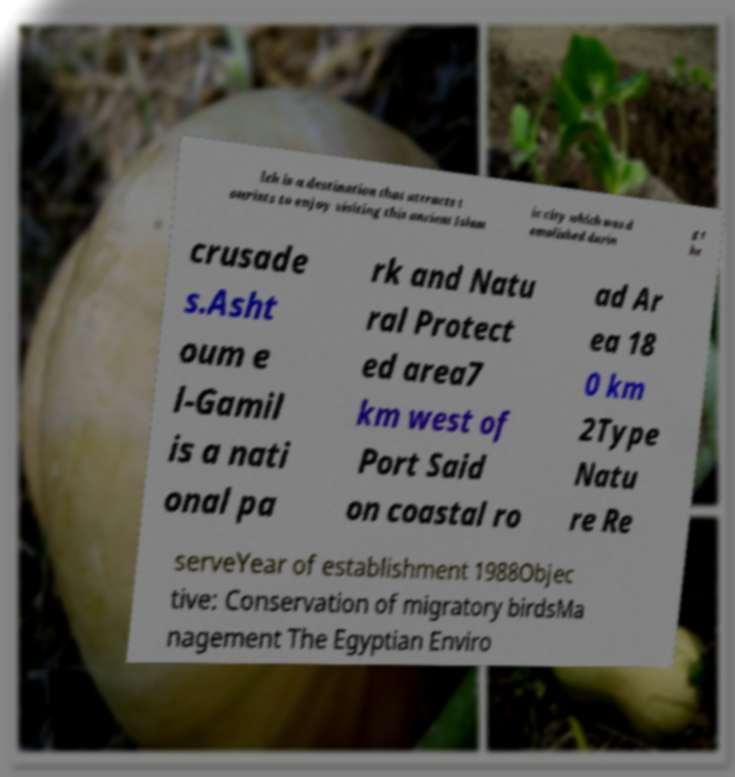Can you accurately transcribe the text from the provided image for me? leh is a destination that attracts t ourists to enjoy visiting this ancient Islam ic city which was d emolished durin g t he crusade s.Asht oum e l-Gamil is a nati onal pa rk and Natu ral Protect ed area7 km west of Port Said on coastal ro ad Ar ea 18 0 km 2Type Natu re Re serveYear of establishment 1988Objec tive: Conservation of migratory birdsMa nagement The Egyptian Enviro 